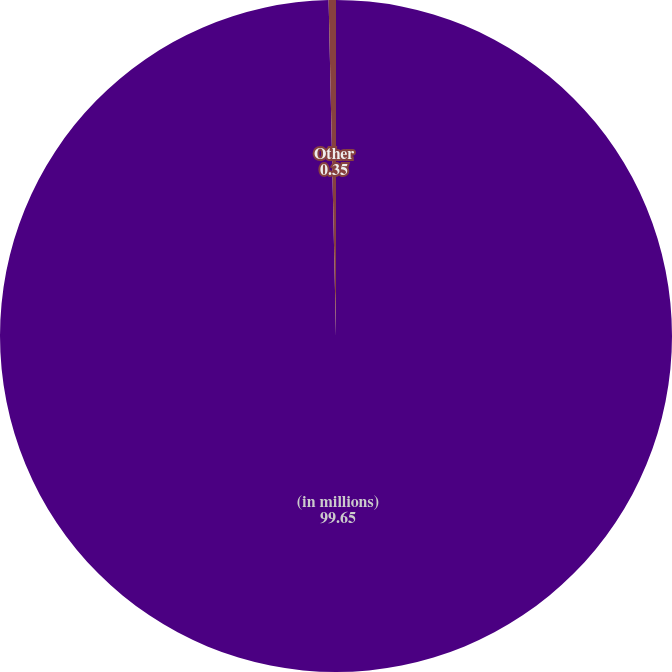Convert chart to OTSL. <chart><loc_0><loc_0><loc_500><loc_500><pie_chart><fcel>(in millions)<fcel>Other<nl><fcel>99.65%<fcel>0.35%<nl></chart> 